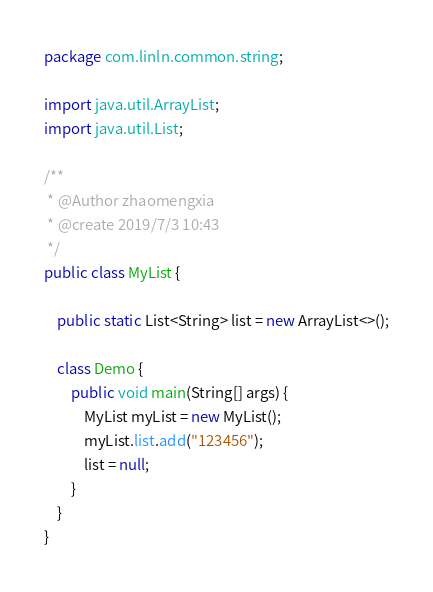<code> <loc_0><loc_0><loc_500><loc_500><_Java_>package com.linln.common.string;

import java.util.ArrayList;
import java.util.List;

/**
 * @Author zhaomengxia
 * @create 2019/7/3 10:43
 */
public class MyList {

    public static List<String> list = new ArrayList<>();

    class Demo {
        public void main(String[] args) {
            MyList myList = new MyList();
            myList.list.add("123456");
            list = null;
        }
    }
}</code> 